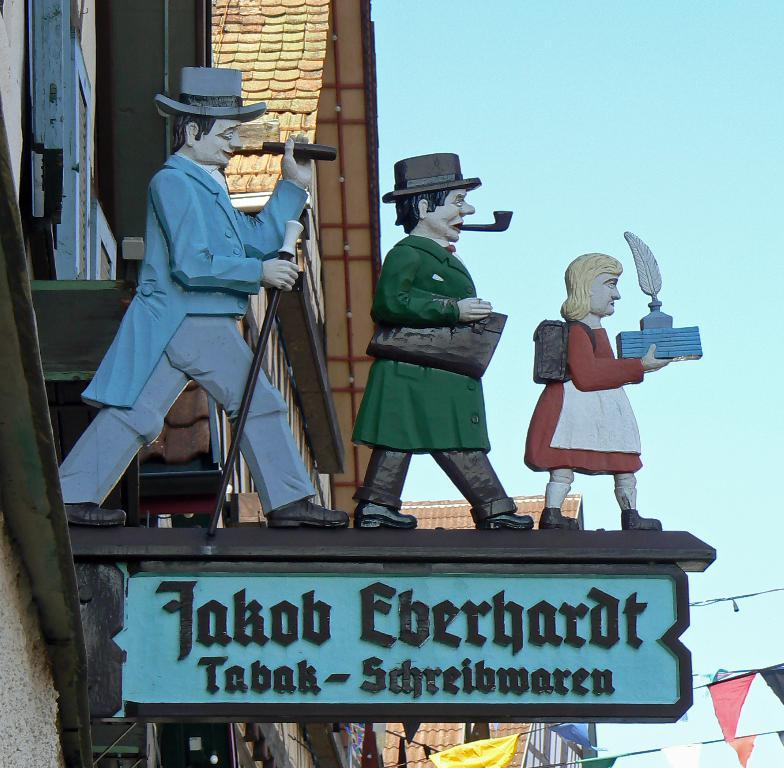What is depicted on the board in the image? There are statues on a board in the image. What can be seen in the distance behind the board? There are buildings in the background of the image. What else is visible in the background of the image? Cables and flags are visible in the background of the image. What color are the dolls sitting on the board in the image? There are no dolls present in the image; it features statues on a board. 